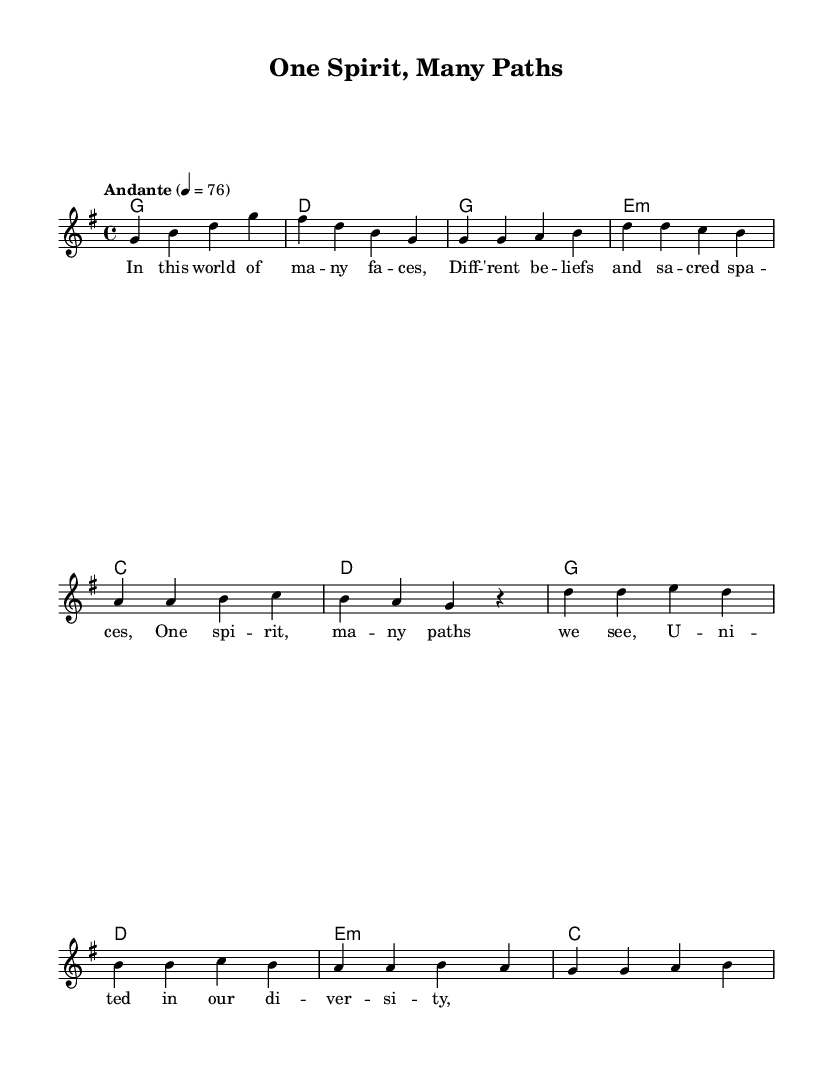What is the key signature of this music? The key signature is G major, which has one sharp (F#). This can be determined by looking at the key signature notation at the beginning of the music sheet.
Answer: G major What is the time signature of this music? The time signature is 4/4, which indicates that there are four beats per measure and the quarter note gets one beat. This is found in the upper left corner of the sheet music.
Answer: 4/4 What is the tempo marking for this piece? The tempo marking is "Andante," which typically indicates a moderate pace. This is indicated in the tempo notation above the staff.
Answer: Andante How many measures are in the verse? There are eight measures in the verse section. Counting the measures indicated in the verse section reveals that there are eight distinct measures.
Answer: Eight What is the tonal center of the chorus section? The tonal center of the chorus is G major, which can be inferred from the melody and harmonies presented in the chorus section and their reliance on the tonic chord.
Answer: G major What is the repeated lyric in the verse? The repeated lyric is "ma," which appears multiple times throughout the verse lines. By scanning the lyrics, one can identify "ma" appearing in different contexts repeatedly.
Answer: ma What does the title "One Spirit, Many Paths" suggest about the theme of the music? The title suggests a theme of unity and diversity in spiritual beliefs. The phrase emphasizes the concept of different paths leading to the same spiritual essence, reflecting interfaith harmony.
Answer: Unity and diversity 